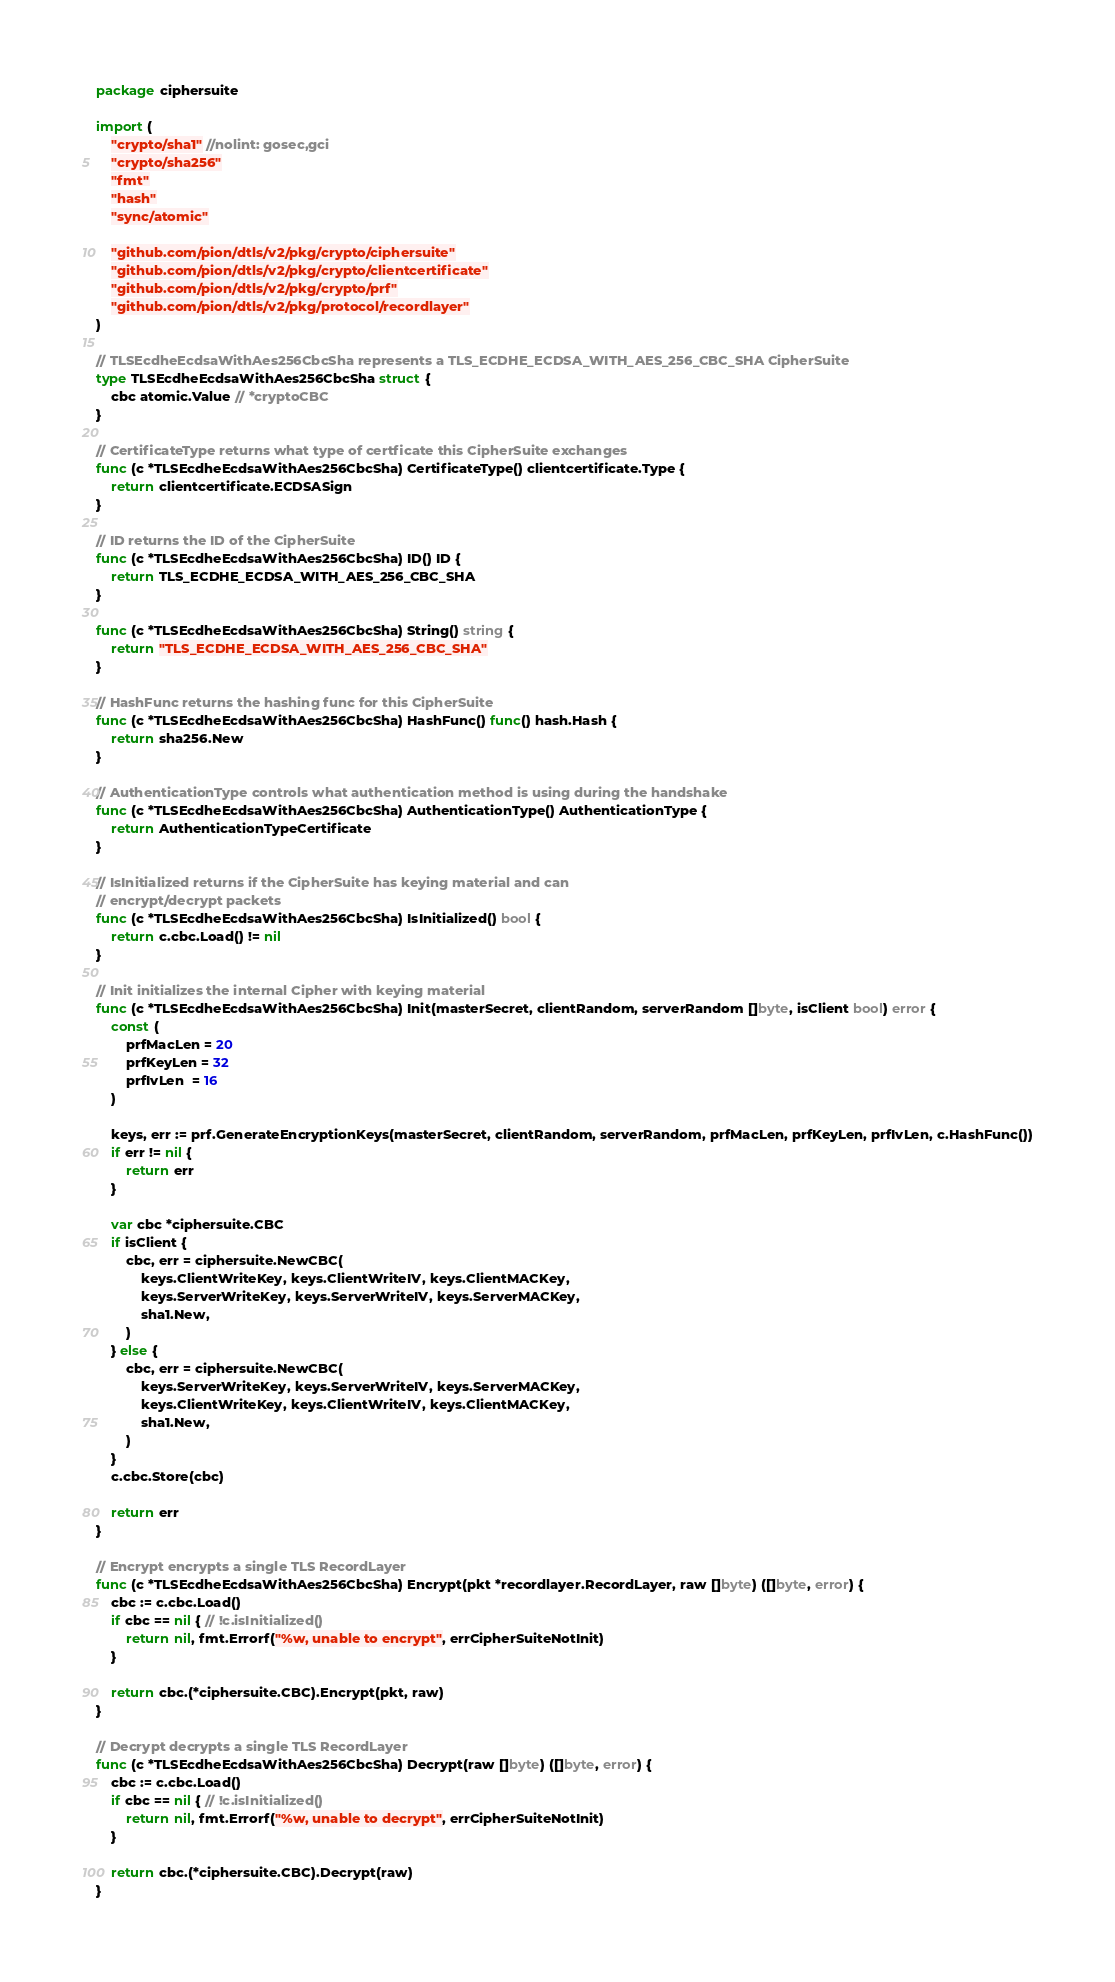Convert code to text. <code><loc_0><loc_0><loc_500><loc_500><_Go_>package ciphersuite

import (
	"crypto/sha1" //nolint: gosec,gci
	"crypto/sha256"
	"fmt"
	"hash"
	"sync/atomic"

	"github.com/pion/dtls/v2/pkg/crypto/ciphersuite"
	"github.com/pion/dtls/v2/pkg/crypto/clientcertificate"
	"github.com/pion/dtls/v2/pkg/crypto/prf"
	"github.com/pion/dtls/v2/pkg/protocol/recordlayer"
)

// TLSEcdheEcdsaWithAes256CbcSha represents a TLS_ECDHE_ECDSA_WITH_AES_256_CBC_SHA CipherSuite
type TLSEcdheEcdsaWithAes256CbcSha struct {
	cbc atomic.Value // *cryptoCBC
}

// CertificateType returns what type of certficate this CipherSuite exchanges
func (c *TLSEcdheEcdsaWithAes256CbcSha) CertificateType() clientcertificate.Type {
	return clientcertificate.ECDSASign
}

// ID returns the ID of the CipherSuite
func (c *TLSEcdheEcdsaWithAes256CbcSha) ID() ID {
	return TLS_ECDHE_ECDSA_WITH_AES_256_CBC_SHA
}

func (c *TLSEcdheEcdsaWithAes256CbcSha) String() string {
	return "TLS_ECDHE_ECDSA_WITH_AES_256_CBC_SHA"
}

// HashFunc returns the hashing func for this CipherSuite
func (c *TLSEcdheEcdsaWithAes256CbcSha) HashFunc() func() hash.Hash {
	return sha256.New
}

// AuthenticationType controls what authentication method is using during the handshake
func (c *TLSEcdheEcdsaWithAes256CbcSha) AuthenticationType() AuthenticationType {
	return AuthenticationTypeCertificate
}

// IsInitialized returns if the CipherSuite has keying material and can
// encrypt/decrypt packets
func (c *TLSEcdheEcdsaWithAes256CbcSha) IsInitialized() bool {
	return c.cbc.Load() != nil
}

// Init initializes the internal Cipher with keying material
func (c *TLSEcdheEcdsaWithAes256CbcSha) Init(masterSecret, clientRandom, serverRandom []byte, isClient bool) error {
	const (
		prfMacLen = 20
		prfKeyLen = 32
		prfIvLen  = 16
	)

	keys, err := prf.GenerateEncryptionKeys(masterSecret, clientRandom, serverRandom, prfMacLen, prfKeyLen, prfIvLen, c.HashFunc())
	if err != nil {
		return err
	}

	var cbc *ciphersuite.CBC
	if isClient {
		cbc, err = ciphersuite.NewCBC(
			keys.ClientWriteKey, keys.ClientWriteIV, keys.ClientMACKey,
			keys.ServerWriteKey, keys.ServerWriteIV, keys.ServerMACKey,
			sha1.New,
		)
	} else {
		cbc, err = ciphersuite.NewCBC(
			keys.ServerWriteKey, keys.ServerWriteIV, keys.ServerMACKey,
			keys.ClientWriteKey, keys.ClientWriteIV, keys.ClientMACKey,
			sha1.New,
		)
	}
	c.cbc.Store(cbc)

	return err
}

// Encrypt encrypts a single TLS RecordLayer
func (c *TLSEcdheEcdsaWithAes256CbcSha) Encrypt(pkt *recordlayer.RecordLayer, raw []byte) ([]byte, error) {
	cbc := c.cbc.Load()
	if cbc == nil { // !c.isInitialized()
		return nil, fmt.Errorf("%w, unable to encrypt", errCipherSuiteNotInit)
	}

	return cbc.(*ciphersuite.CBC).Encrypt(pkt, raw)
}

// Decrypt decrypts a single TLS RecordLayer
func (c *TLSEcdheEcdsaWithAes256CbcSha) Decrypt(raw []byte) ([]byte, error) {
	cbc := c.cbc.Load()
	if cbc == nil { // !c.isInitialized()
		return nil, fmt.Errorf("%w, unable to decrypt", errCipherSuiteNotInit)
	}

	return cbc.(*ciphersuite.CBC).Decrypt(raw)
}
</code> 